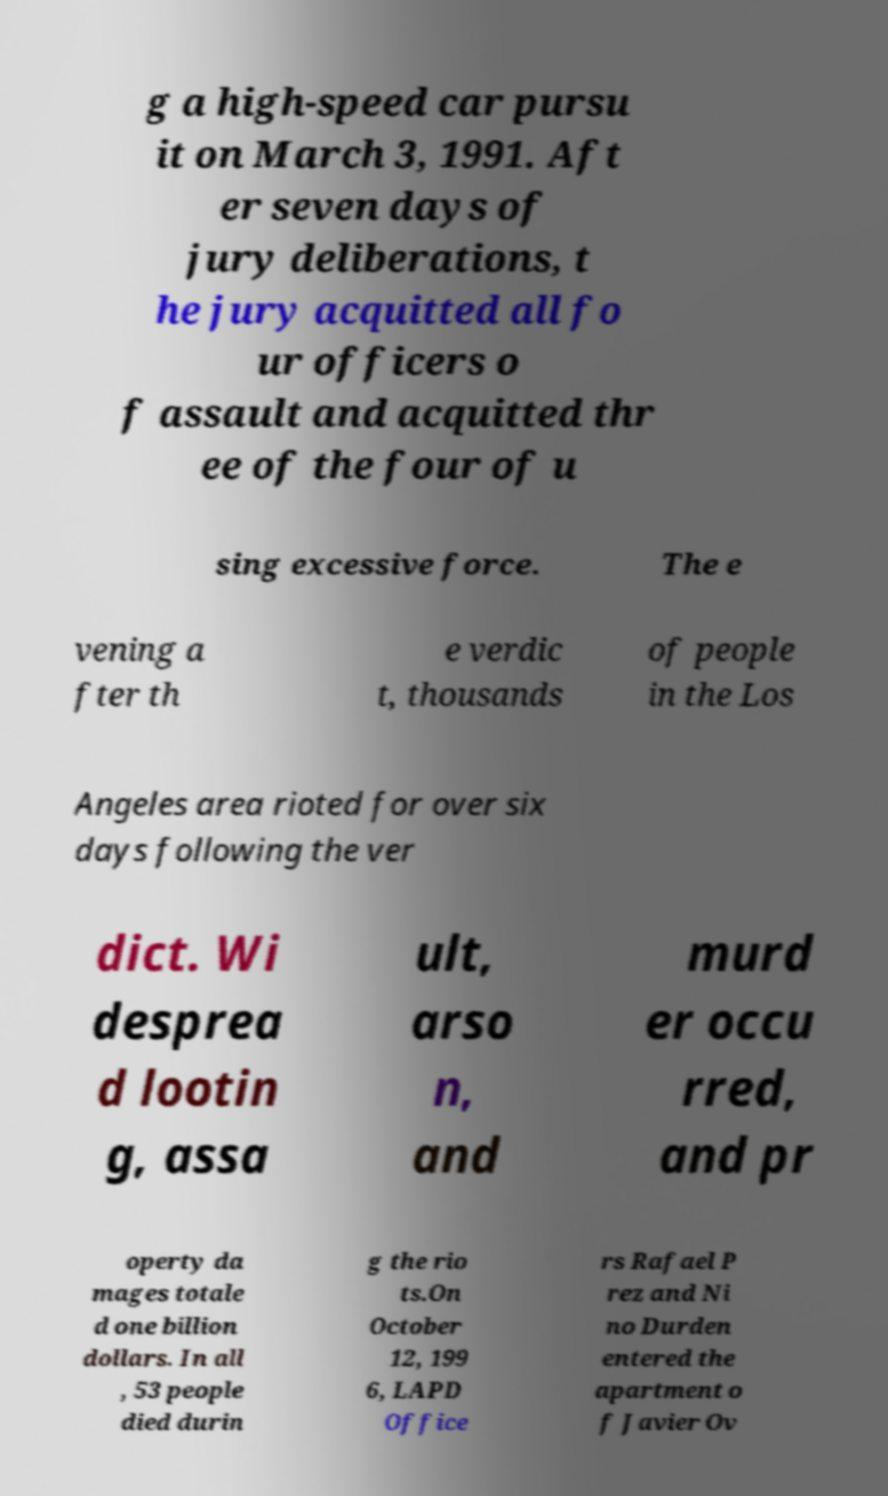Can you read and provide the text displayed in the image?This photo seems to have some interesting text. Can you extract and type it out for me? g a high-speed car pursu it on March 3, 1991. Aft er seven days of jury deliberations, t he jury acquitted all fo ur officers o f assault and acquitted thr ee of the four of u sing excessive force. The e vening a fter th e verdic t, thousands of people in the Los Angeles area rioted for over six days following the ver dict. Wi desprea d lootin g, assa ult, arso n, and murd er occu rred, and pr operty da mages totale d one billion dollars. In all , 53 people died durin g the rio ts.On October 12, 199 6, LAPD Office rs Rafael P rez and Ni no Durden entered the apartment o f Javier Ov 